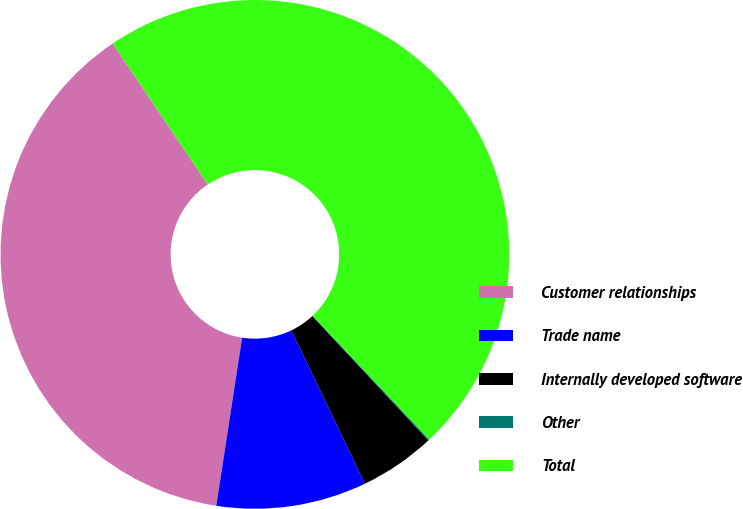<chart> <loc_0><loc_0><loc_500><loc_500><pie_chart><fcel>Customer relationships<fcel>Trade name<fcel>Internally developed software<fcel>Other<fcel>Total<nl><fcel>38.13%<fcel>9.55%<fcel>4.82%<fcel>0.08%<fcel>47.42%<nl></chart> 